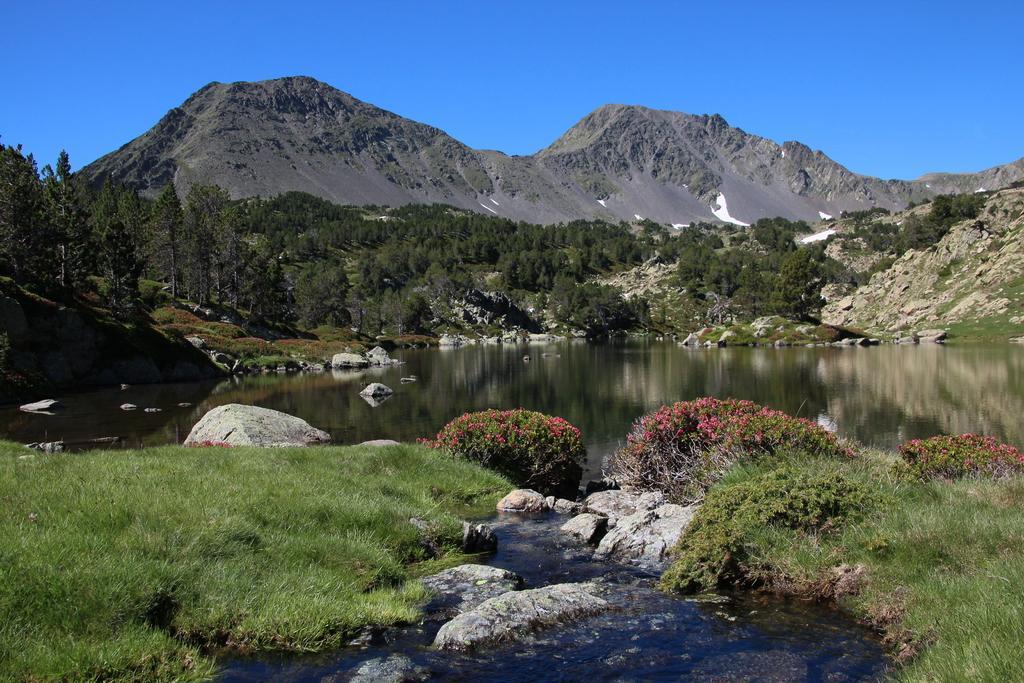Please provide a concise description of this image. In this image we can see there is a river, rocks, grass, plants, trees, mountains and a sky. 